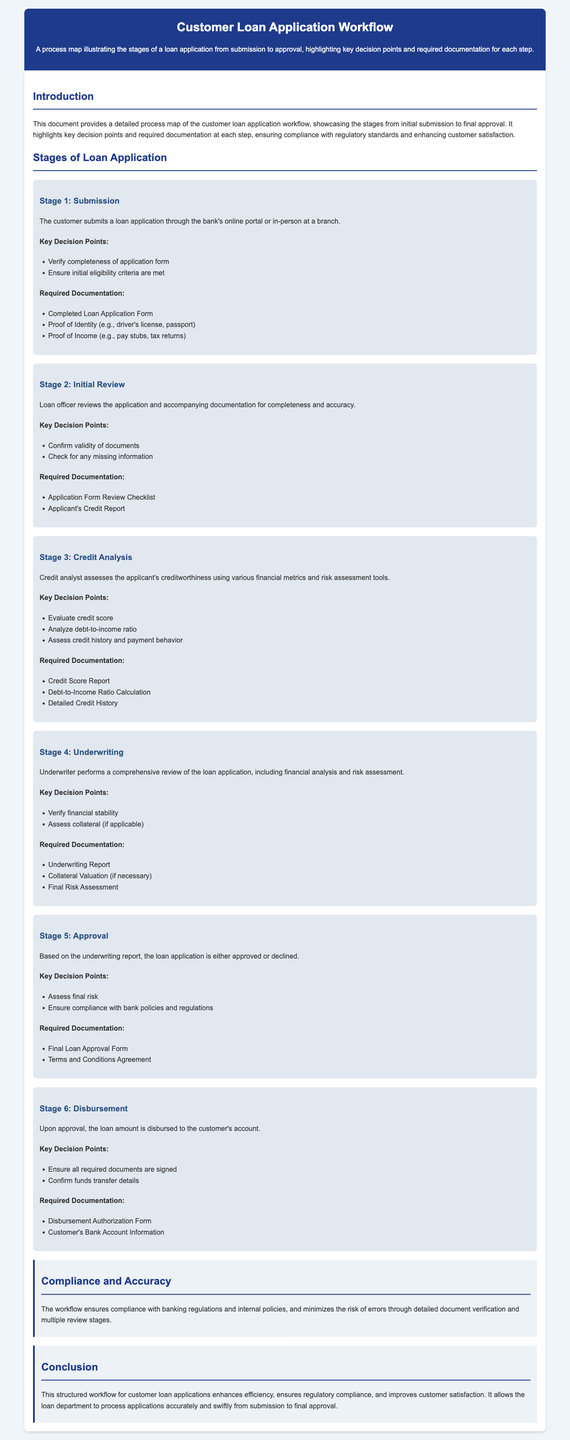What is the first stage of the loan application workflow? The first stage is the initial step in the loan application process as stated in the document.
Answer: Submission What documentation is required for the initial review stage? This documentation is listed under the "Required Documentation" section for the initial review stage.
Answer: Application Form Review Checklist, Applicant's Credit Report How many key decision points are there in the credit analysis stage? This is determined by counting the key decision points listed in the credit analysis section.
Answer: Three What does the loan officer confirm during the initial review? The specifics of what the loan officer confirms are outlined in the key decision points for the initial review stage.
Answer: Validity of documents What is the last stage of the loan application process? The last stage is indicated in the stages of the loan application section.
Answer: Disbursement What type of report is required for underwriting? This is mentioned under the required documentation for the underwriting stage.
Answer: Underwriting Report How many stages are there in the loan application workflow? The total number is specified in the stages section of the document.
Answer: Six What is emphasized in the compliance section of the document? The key focus of the compliance section is summarized in the text provided under that heading.
Answer: Compliance with banking regulations What enhances customer satisfaction in the loan application process? The conclusion section highlights factors contributing to customer satisfaction.
Answer: Structured workflow 